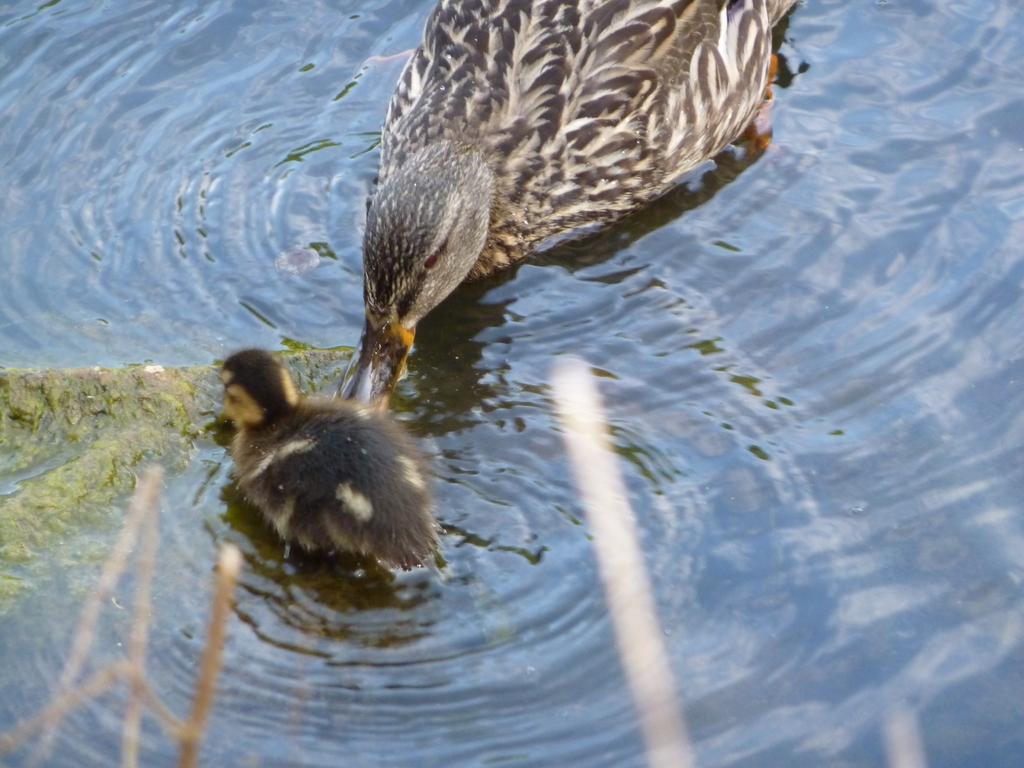Could you give a brief overview of what you see in this image? In this picture, we see a duck and the baby duck are drinking water. This water might be in the pond. 